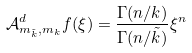<formula> <loc_0><loc_0><loc_500><loc_500>\mathcal { A } _ { m _ { \tilde { k } } , m _ { k } } ^ { d } f ( \xi ) = \frac { \Gamma ( n / k ) } { \Gamma ( n / \tilde { k } ) } \xi ^ { n }</formula> 